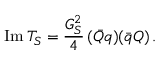Convert formula to latex. <formula><loc_0><loc_0><loc_500><loc_500>I m \, T _ { S } = \frac { G _ { S } ^ { 2 } } { 4 } \, ( \bar { Q } q ) ( \bar { q } Q ) \, .</formula> 